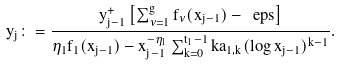Convert formula to latex. <formula><loc_0><loc_0><loc_500><loc_500>y _ { j } \colon = \frac { y ^ { + } _ { j - 1 } \left [ \sum _ { \nu = 1 } ^ { g } f _ { \nu } ( x _ { j - 1 } ) - \ e p s \right ] } { \eta _ { 1 } f _ { 1 } ( x _ { j - 1 } ) - x _ { j - 1 } ^ { - \eta _ { 1 } } \sum _ { k = 0 } ^ { t _ { 1 } - 1 } k a _ { 1 , k } ( \log x _ { j - 1 } ) ^ { k - 1 } } .</formula> 